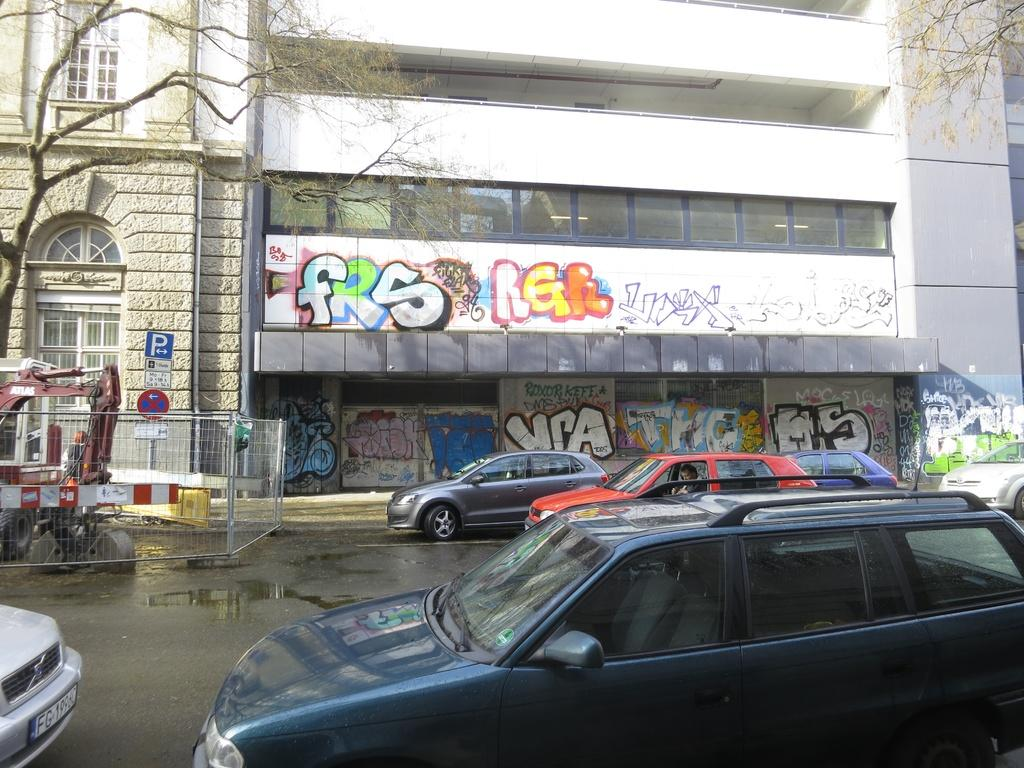What type of structures can be seen in the image? There are buildings in the image. What is present on the walls of the buildings? There is graffiti on the walls in the image. What type of information might be displayed on the sign boards in the image? The sign boards in the image might display information such as directions, advertisements, or warnings. What type of barrier is present in the image? There are fences in the image. What type of transportation is visible on the road in the image? Motor vehicles are visible on the road in the image. What type of vegetation is present in the image? Trees are present in the image. What type of lighting is visible in the image? Electric lights are visible in the image. How much sugar is present in the image? There is no sugar present in the image. Can you see a duck in the image? There is no duck present in the image. 